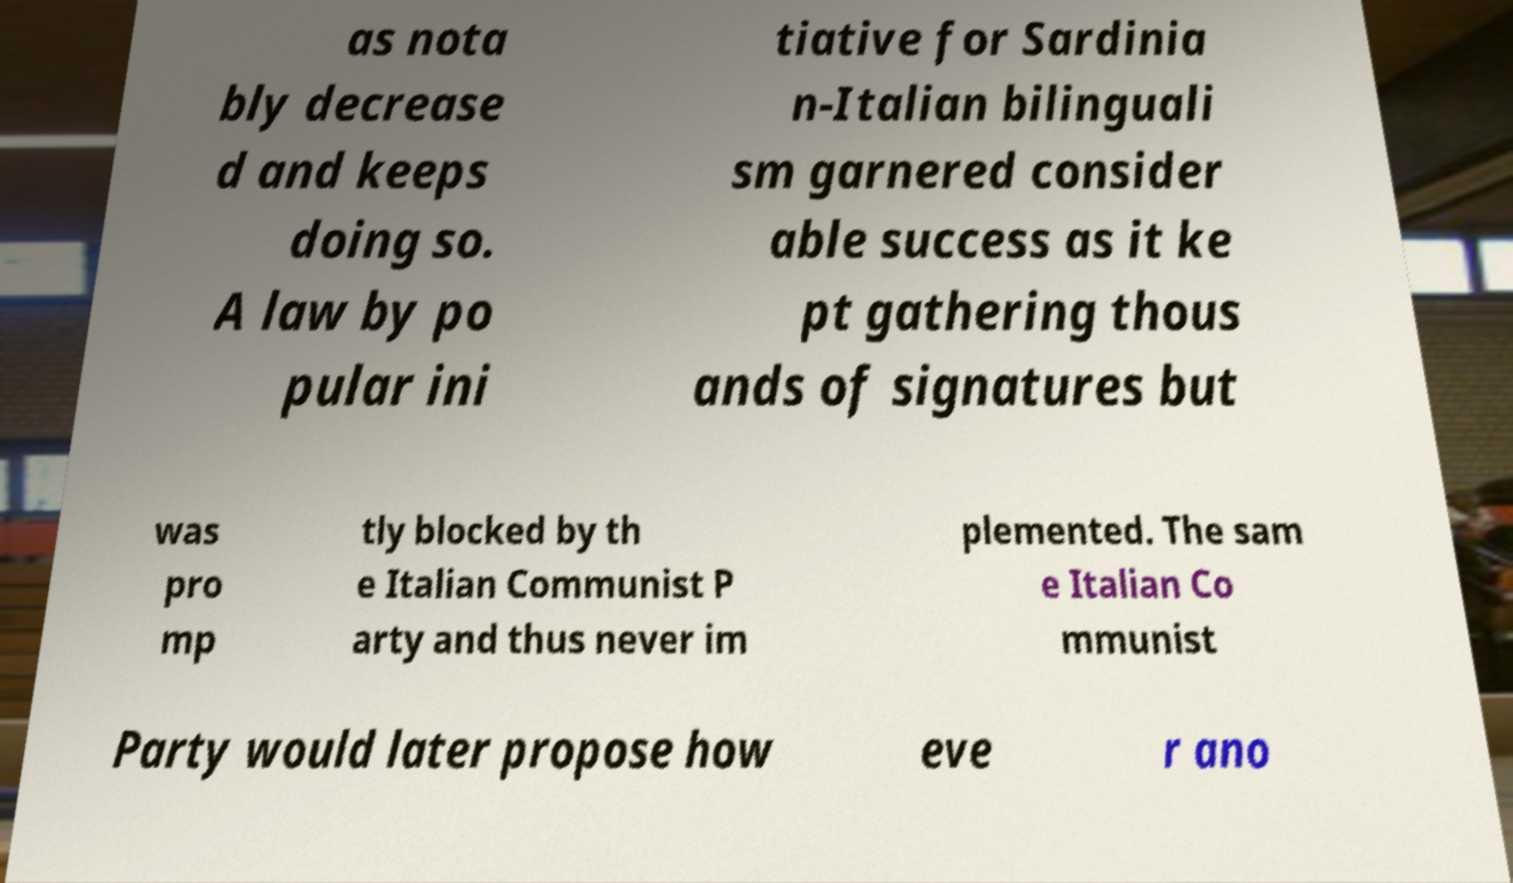What messages or text are displayed in this image? I need them in a readable, typed format. as nota bly decrease d and keeps doing so. A law by po pular ini tiative for Sardinia n-Italian bilinguali sm garnered consider able success as it ke pt gathering thous ands of signatures but was pro mp tly blocked by th e Italian Communist P arty and thus never im plemented. The sam e Italian Co mmunist Party would later propose how eve r ano 